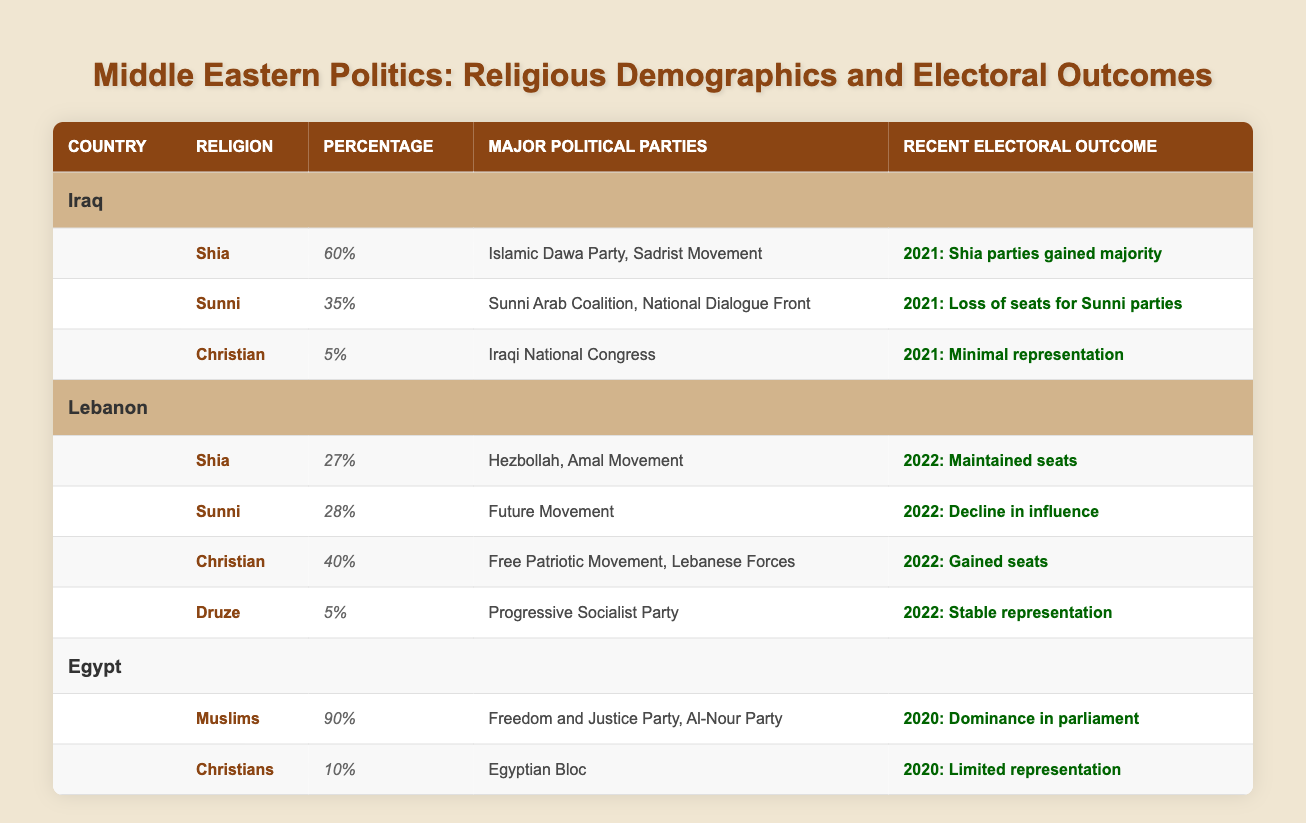What percentage of Muslims is there in Egypt? The table shows that Muslims constitute 90% of the population in Egypt under the religious demographics section.
Answer: 90% Which religious group in Iraq has the highest percentage? According to the table, the Shia demographic in Iraq is 60%, which is higher than the Sunni percentage of 35% and the Christian percentage of 5%.
Answer: Shia Did the Shia parties gain a majority in the most recent election in Iraq? The recent electoral outcome for Iraq in 2021 indicates that Shia parties gained a majority in the election results.
Answer: Yes What was the outcome for Christian representation in Iraq's recent election? The table states that in the 2021 election, the result for Christian representation was minimal, indicating a low level of political influence.
Answer: Minimal representation What is the combined percentage of Shia and Sunni populations in Lebanon? The Shia percentage is 27%, and the Sunni percentage is 28%. Adding these two gives us 27 + 28 = 55%. Therefore, the combined percentage is 55%.
Answer: 55% How many major political parties represent Christians in Lebanon? The table lists two major political parties that represent Christians in Lebanon, which are the Free Patriotic Movement and the Lebanese Forces.
Answer: 2 In which country did the Muslims achieve dominance in parliament? The information on electoral outcomes indicates that in Egypt, Muslims achieved dominance in parliament during the 2020 elections.
Answer: Egypt What was the outcome for Sunni parties in the most recent elections in Iraq? The recent electoral outcome for Sunni parties in Iraq in 2021 shows a loss of seats for these parties, indicating a decline in their political standing.
Answer: Loss of seats Which religious group in Lebanon gained seats in the most recent election? The table shows that the Christian demographic in Lebanon gained seats in the 2022 elections, as indicated in their recent electoral outcome.
Answer: Christian What percentage of total religious demographics does the Druze group represent in Lebanon? The Druze demographic represents 5% of the population in Lebanon according to the table, which is explicitly listed in the religious demographics section.
Answer: 5% 